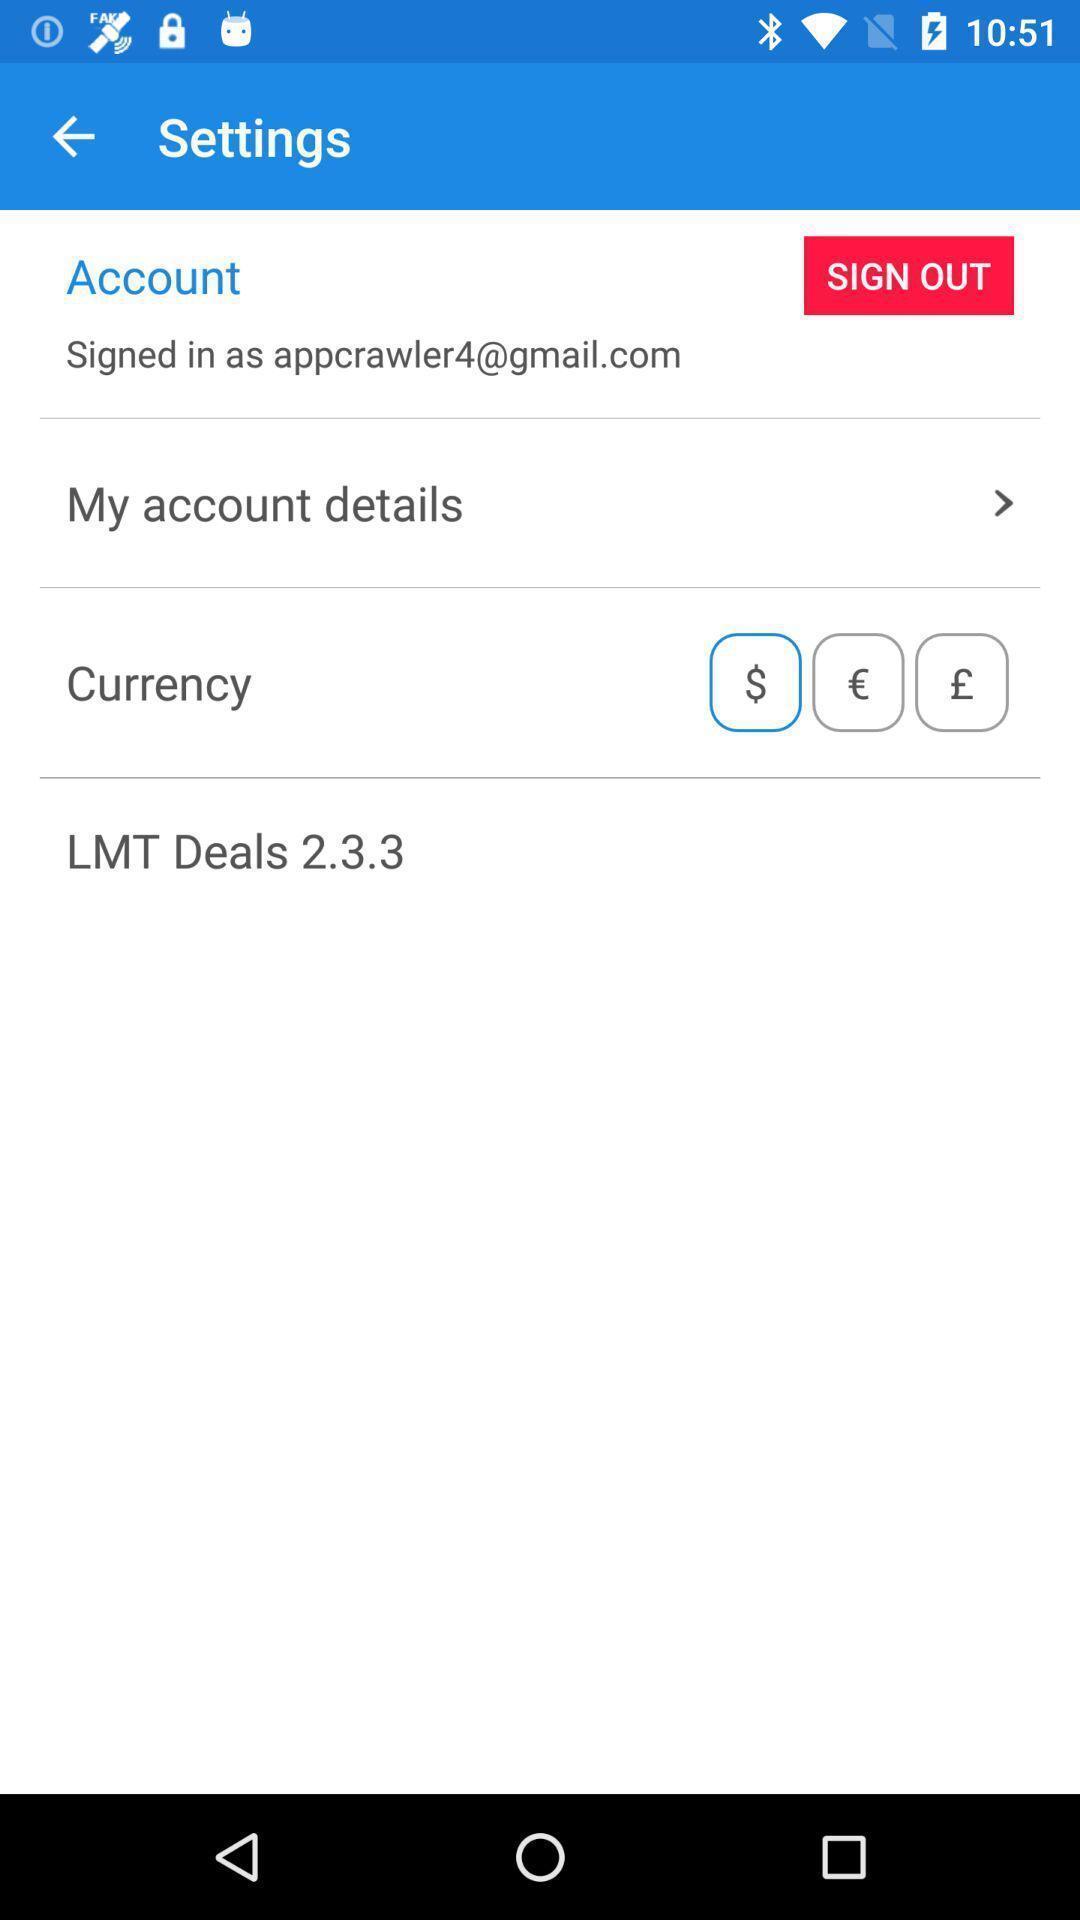Describe the key features of this screenshot. Settings page. 